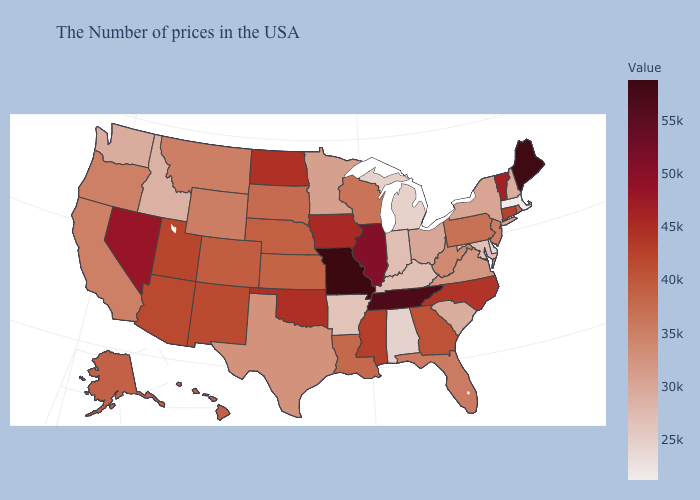Is the legend a continuous bar?
Keep it brief. Yes. Which states hav the highest value in the West?
Keep it brief. Nevada. Is the legend a continuous bar?
Concise answer only. Yes. Does South Dakota have a higher value than Kentucky?
Give a very brief answer. Yes. Among the states that border Arkansas , does Missouri have the lowest value?
Write a very short answer. No. Is the legend a continuous bar?
Concise answer only. Yes. 